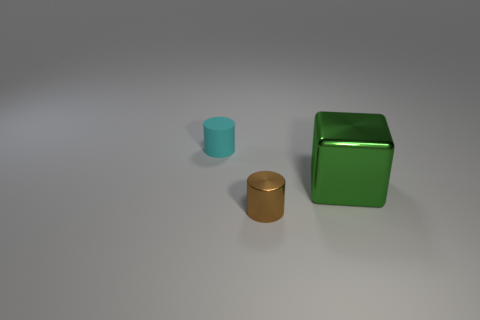How many small objects are metallic cylinders or gray cubes? In the image, there are two objects that match the description: one metallic cylinder and one cube that could be considered gray depending on the perception of color. So, there are two objects that are either metallic cylinders or cubes with a shade of gray. 